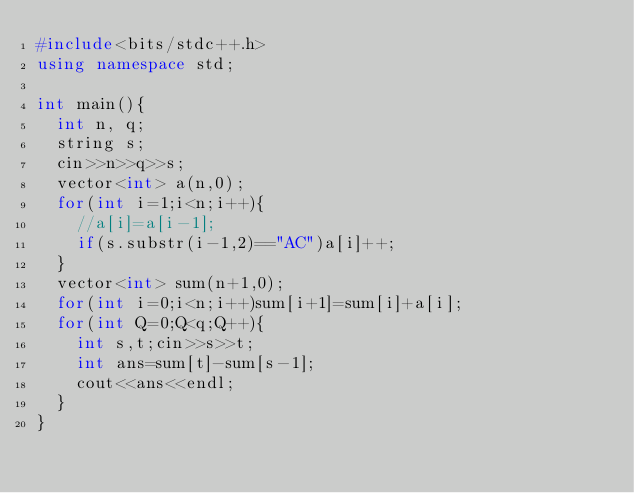<code> <loc_0><loc_0><loc_500><loc_500><_C++_>#include<bits/stdc++.h>
using namespace std;

int main(){
  int n, q;
  string s;
  cin>>n>>q>>s;
  vector<int> a(n,0);
  for(int i=1;i<n;i++){
    //a[i]=a[i-1];
    if(s.substr(i-1,2)=="AC")a[i]++;
  }
  vector<int> sum(n+1,0);
  for(int i=0;i<n;i++)sum[i+1]=sum[i]+a[i];
  for(int Q=0;Q<q;Q++){
    int s,t;cin>>s>>t;
    int ans=sum[t]-sum[s-1];
    cout<<ans<<endl;
  }
}</code> 